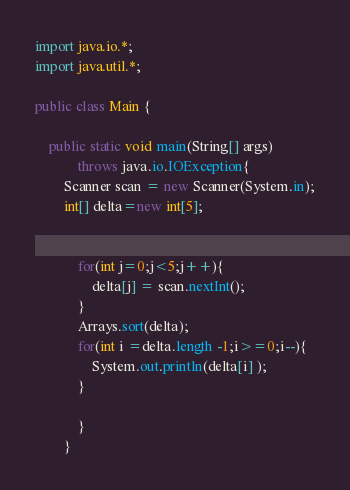Convert code to text. <code><loc_0><loc_0><loc_500><loc_500><_Java_>import java.io.*;
import java.util.*;

public class Main {

	public static void main(String[] args)
			throws java.io.IOException{
		Scanner scan = new Scanner(System.in);
		int[] delta=new int[5];

		
			for(int j=0;j<5;j++){
				delta[j] = scan.nextInt();	
			}
			Arrays.sort(delta);
			for(int i =delta.length -1;i>=0;i--){
				System.out.println(delta[i] );
			}
		
			}
		}</code> 